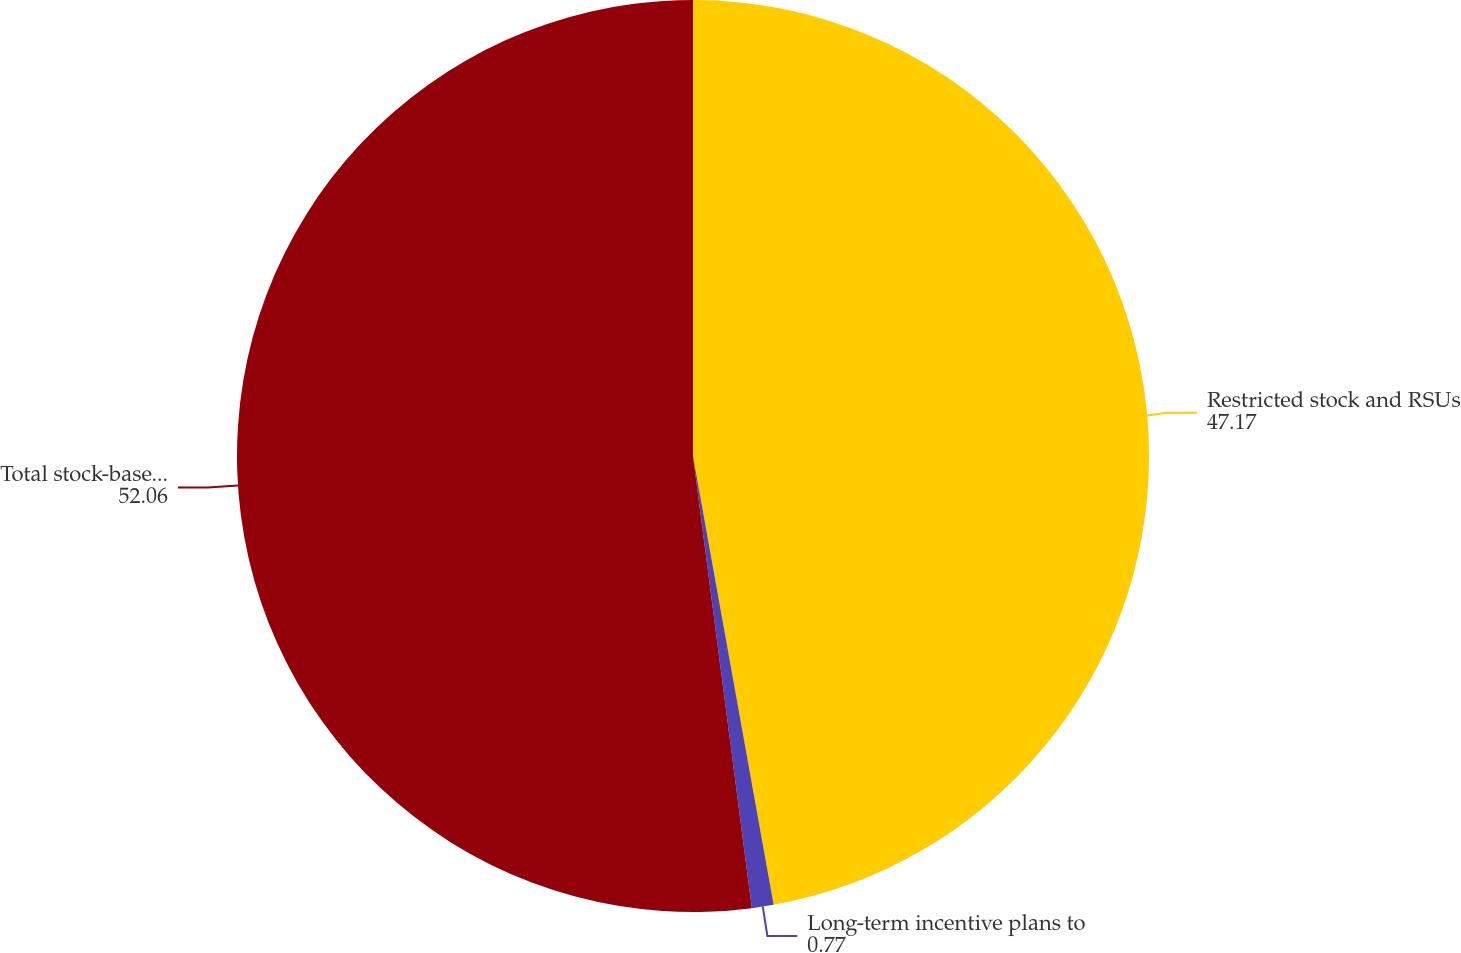Convert chart. <chart><loc_0><loc_0><loc_500><loc_500><pie_chart><fcel>Restricted stock and RSUs<fcel>Long-term incentive plans to<fcel>Total stock-based compensation<nl><fcel>47.17%<fcel>0.77%<fcel>52.06%<nl></chart> 